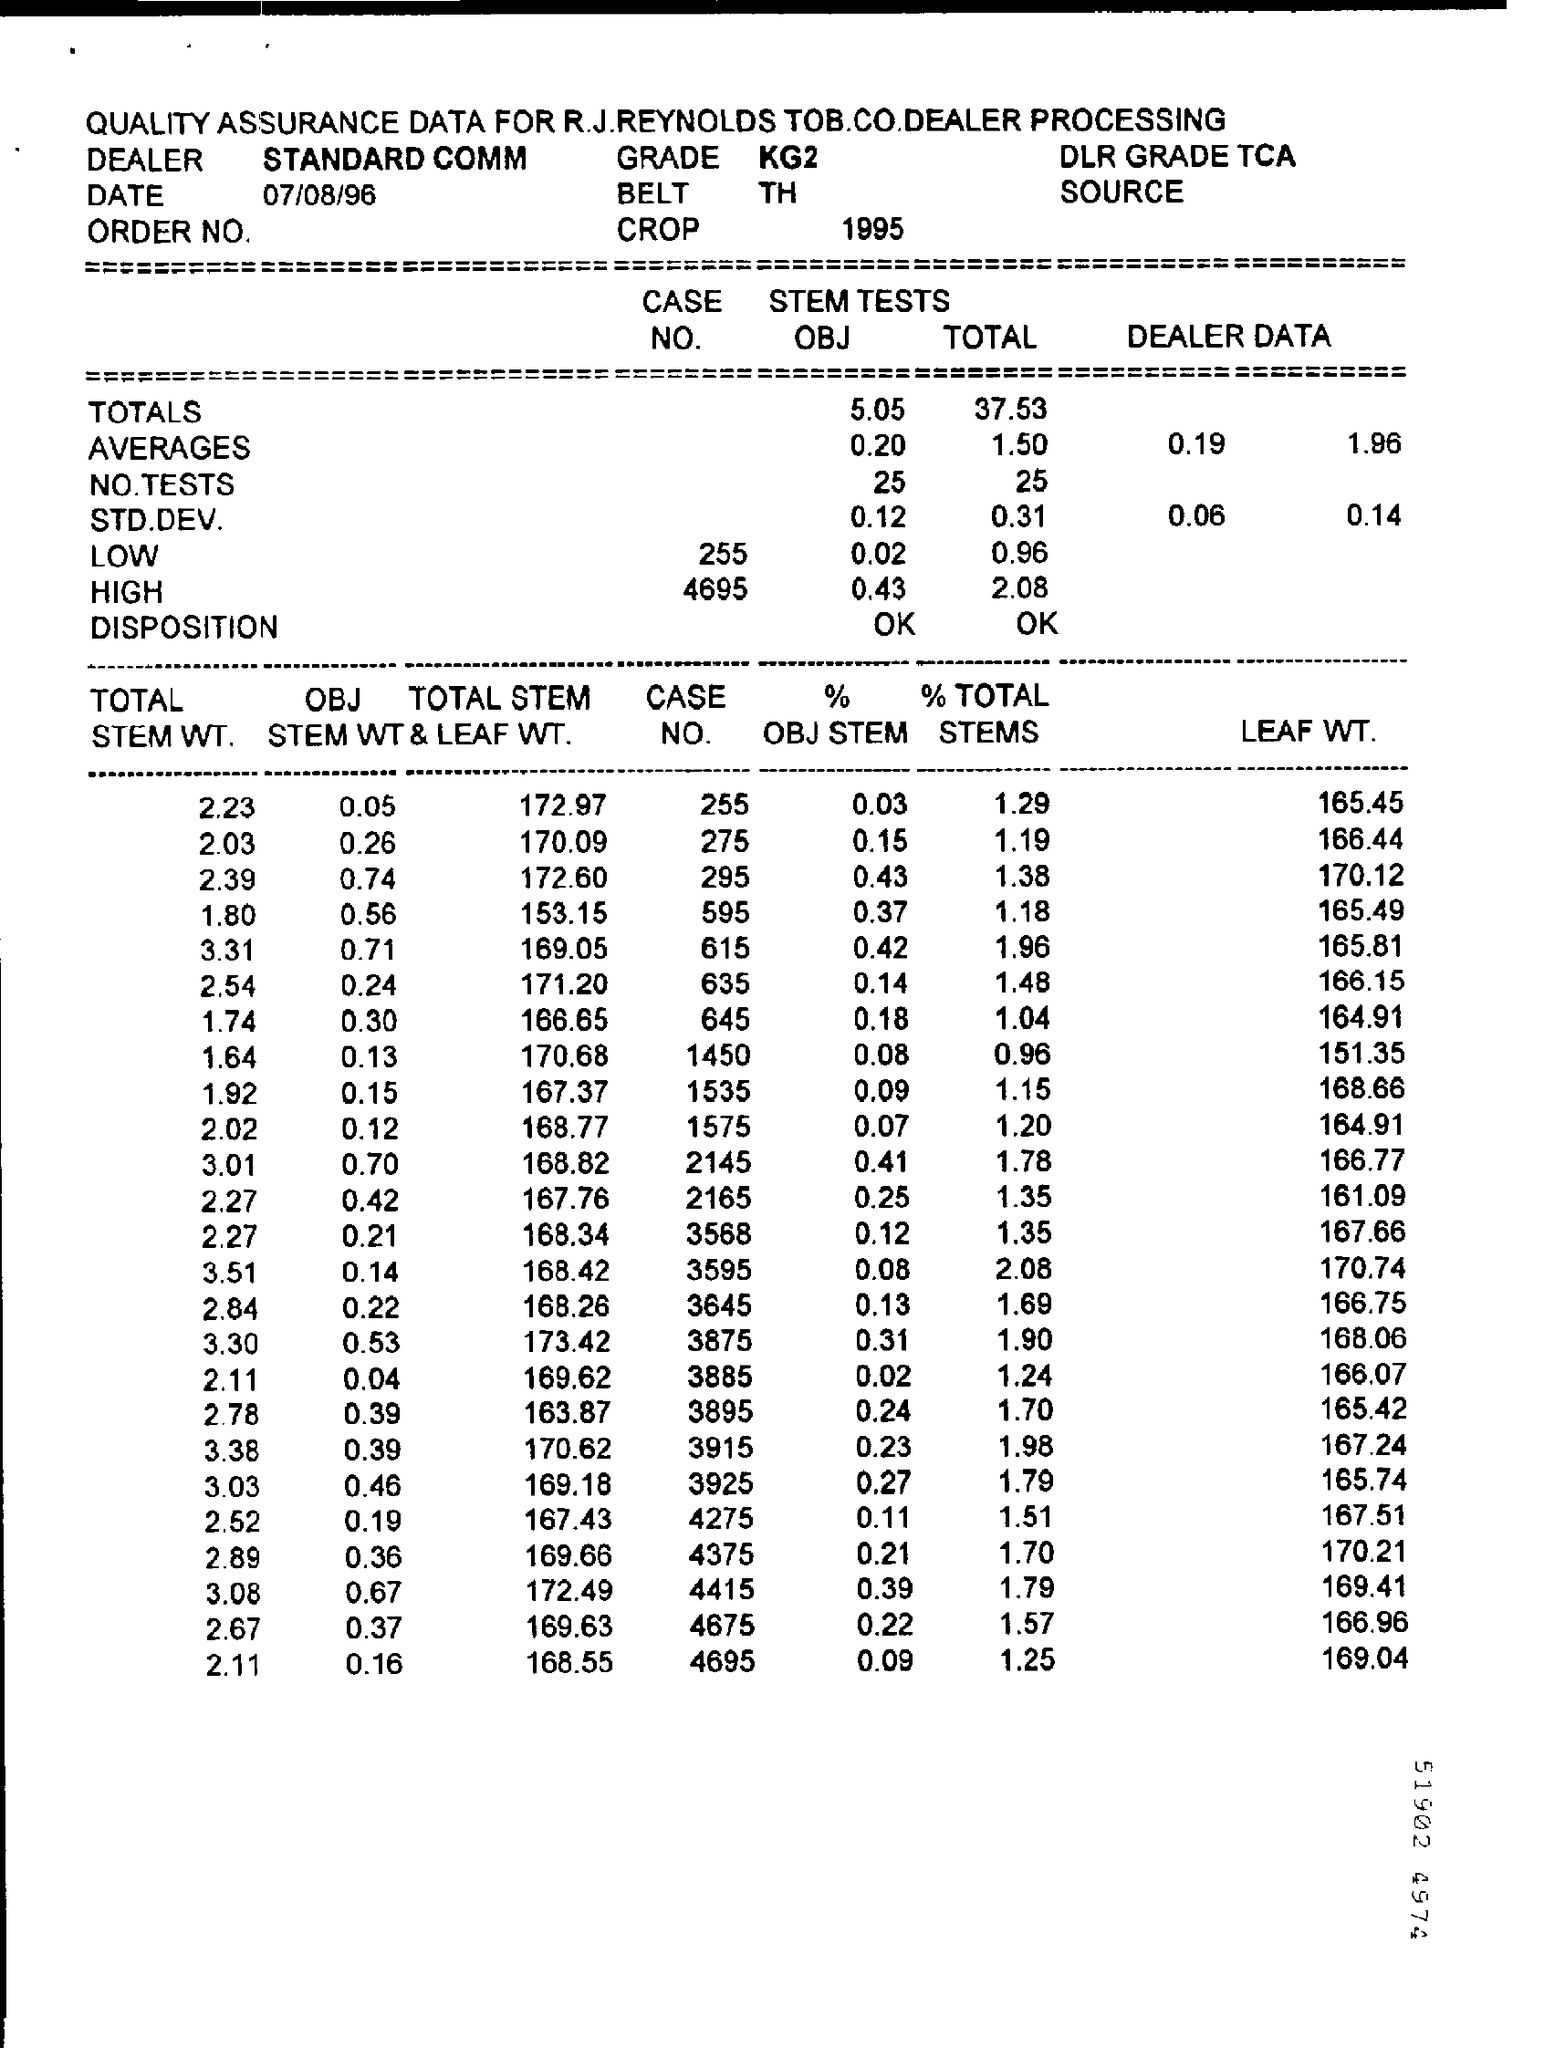Who is DEALER?
Offer a very short reply. STANDARD COMM. If the TOTAL STEM  WT is 1.80 then whats the %OBJ STEM?
Keep it short and to the point. 0.37. If % TOTAL STEMS was 2.08 then whats the LEAF WT?
Your answer should be compact. 170.74. Whats the least LEAF WT in chart?
Offer a terse response. 151.35. What is the last CASE NO?
Provide a succinct answer. 4695. If the OBJ STEM WT is 0.21 then whats the TOTAL STEM& LEAF WT?
Your response must be concise. 168.34. 